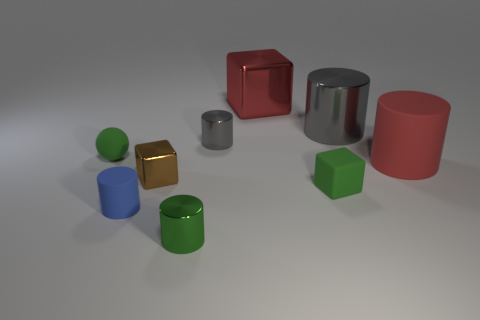Subtract all green cylinders. How many cylinders are left? 4 Subtract all red matte cylinders. How many cylinders are left? 4 Subtract all purple cylinders. Subtract all gray cubes. How many cylinders are left? 5 Subtract all cubes. How many objects are left? 6 Subtract all yellow metallic balls. Subtract all tiny blue matte things. How many objects are left? 8 Add 1 cylinders. How many cylinders are left? 6 Add 4 tiny objects. How many tiny objects exist? 10 Subtract 0 purple spheres. How many objects are left? 9 